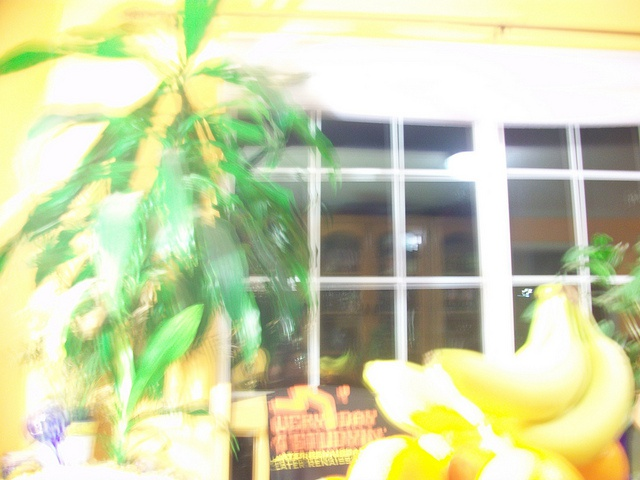Describe the objects in this image and their specific colors. I can see potted plant in gold, khaki, lightgreen, beige, and green tones, banana in gold, beige, khaki, and yellow tones, and banana in gold, ivory, yellow, and khaki tones in this image. 